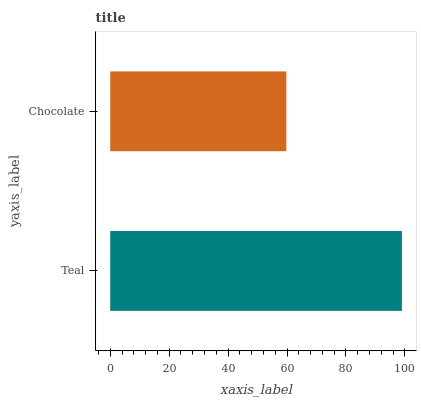Is Chocolate the minimum?
Answer yes or no. Yes. Is Teal the maximum?
Answer yes or no. Yes. Is Chocolate the maximum?
Answer yes or no. No. Is Teal greater than Chocolate?
Answer yes or no. Yes. Is Chocolate less than Teal?
Answer yes or no. Yes. Is Chocolate greater than Teal?
Answer yes or no. No. Is Teal less than Chocolate?
Answer yes or no. No. Is Teal the high median?
Answer yes or no. Yes. Is Chocolate the low median?
Answer yes or no. Yes. Is Chocolate the high median?
Answer yes or no. No. Is Teal the low median?
Answer yes or no. No. 